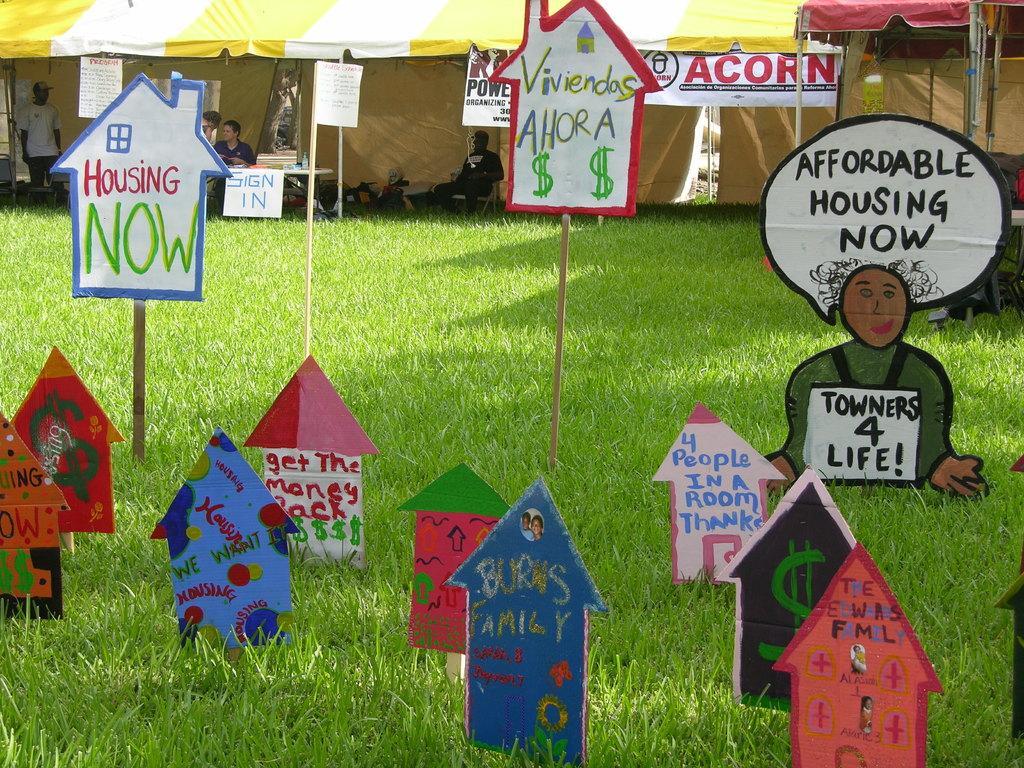Please provide a concise description of this image. In the background we can see the tents, people and objects. In this picture we can see few objects on a table. We can see there is something written on the boards. We can see the poles, boards and the green grass. 